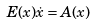Convert formula to latex. <formula><loc_0><loc_0><loc_500><loc_500>E ( x ) \dot { x } = A ( x )</formula> 